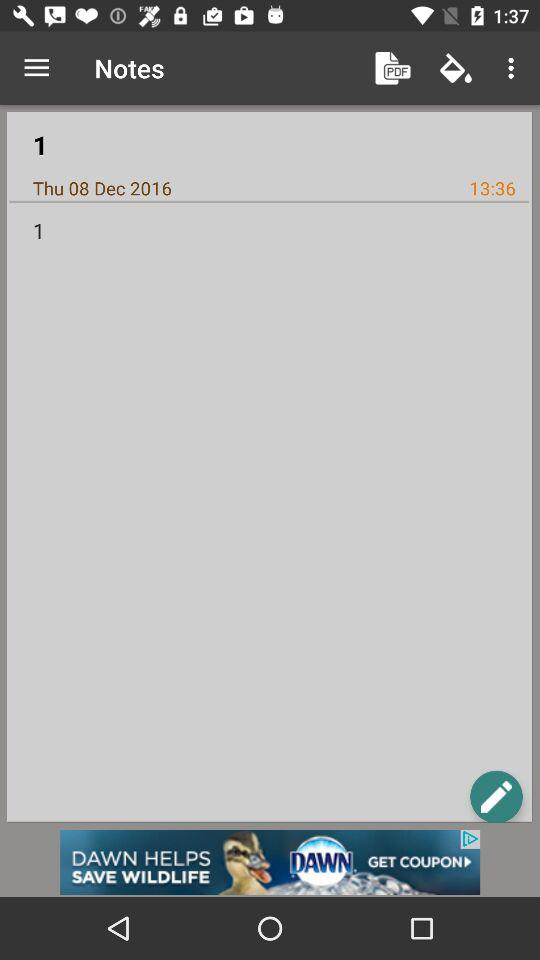What is the title of the note? The title of the note is "1". 